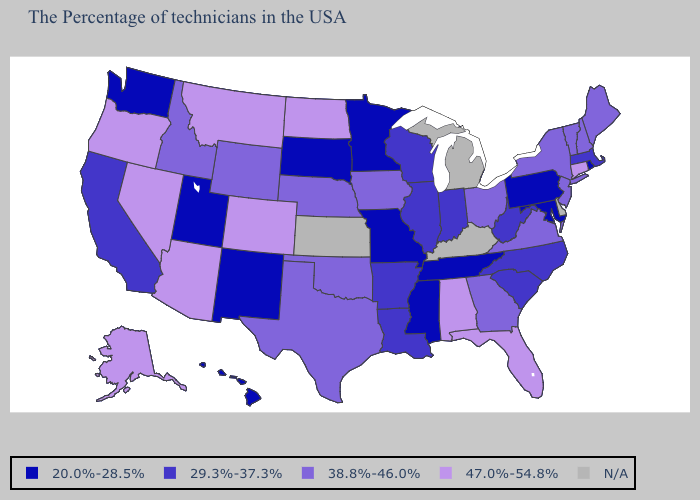Among the states that border Louisiana , which have the highest value?
Quick response, please. Texas. Does Massachusetts have the highest value in the Northeast?
Concise answer only. No. Is the legend a continuous bar?
Keep it brief. No. Which states have the lowest value in the USA?
Short answer required. Rhode Island, Maryland, Pennsylvania, Tennessee, Mississippi, Missouri, Minnesota, South Dakota, New Mexico, Utah, Washington, Hawaii. Among the states that border Florida , does Georgia have the lowest value?
Give a very brief answer. Yes. What is the lowest value in the USA?
Answer briefly. 20.0%-28.5%. What is the lowest value in states that border Iowa?
Keep it brief. 20.0%-28.5%. Among the states that border Nebraska , which have the lowest value?
Concise answer only. Missouri, South Dakota. What is the value of Michigan?
Concise answer only. N/A. What is the value of Idaho?
Write a very short answer. 38.8%-46.0%. Does the map have missing data?
Give a very brief answer. Yes. What is the highest value in states that border Massachusetts?
Write a very short answer. 47.0%-54.8%. Among the states that border South Dakota , does Wyoming have the highest value?
Be succinct. No. Does Arizona have the highest value in the USA?
Concise answer only. Yes. 